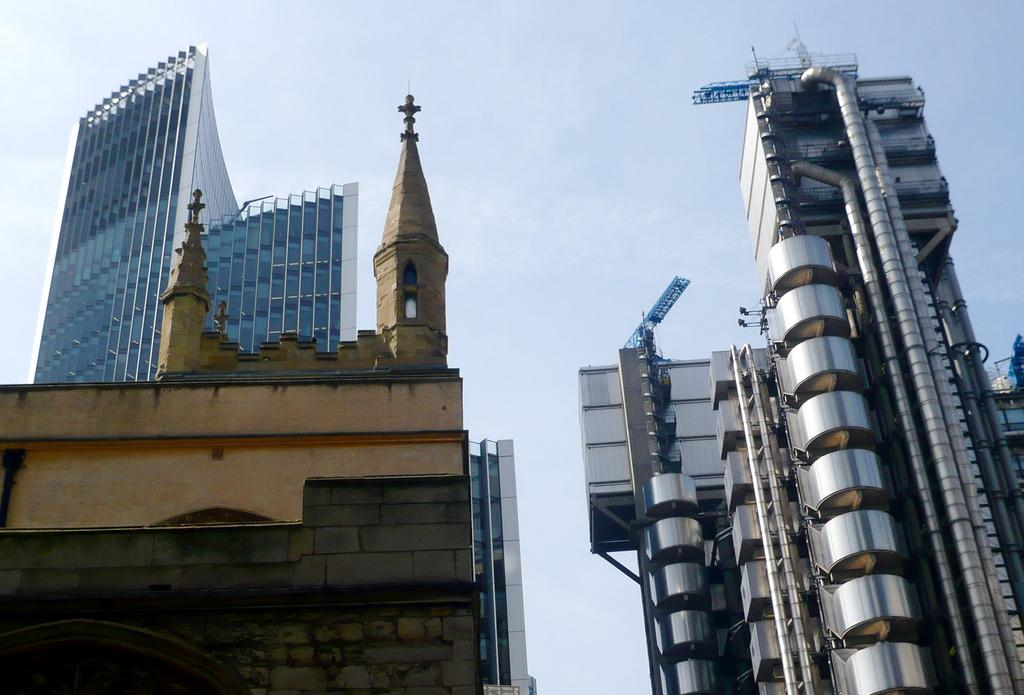What is the main subject in the foreground of the image? There is an architecture in the foreground of the image. What can be seen beside the architecture? There is an organization beside the architecture. What type of structures can be seen in the background of the image? There are huge buildings in the background of the image. How many toes are visible on the architecture in the image? There are no toes present on the architecture in the image, as it is a building and not a living being. 